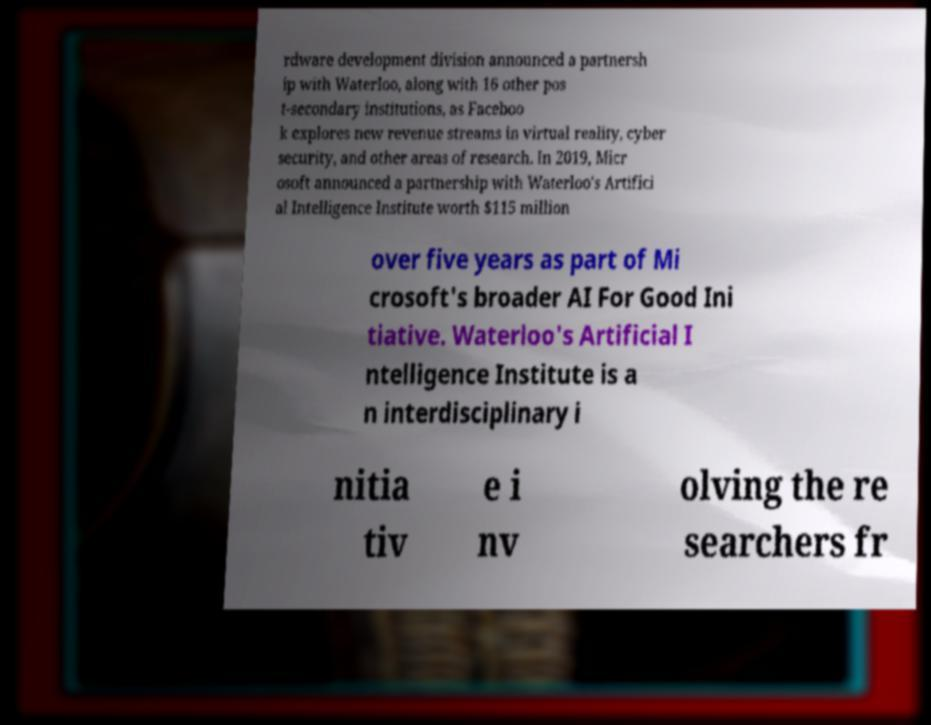I need the written content from this picture converted into text. Can you do that? rdware development division announced a partnersh ip with Waterloo, along with 16 other pos t-secondary institutions, as Faceboo k explores new revenue streams in virtual reality, cyber security, and other areas of research. In 2019, Micr osoft announced a partnership with Waterloo's Artifici al Intelligence Institute worth $115 million over five years as part of Mi crosoft's broader AI For Good Ini tiative. Waterloo's Artificial I ntelligence Institute is a n interdisciplinary i nitia tiv e i nv olving the re searchers fr 